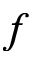Convert formula to latex. <formula><loc_0><loc_0><loc_500><loc_500>f</formula> 